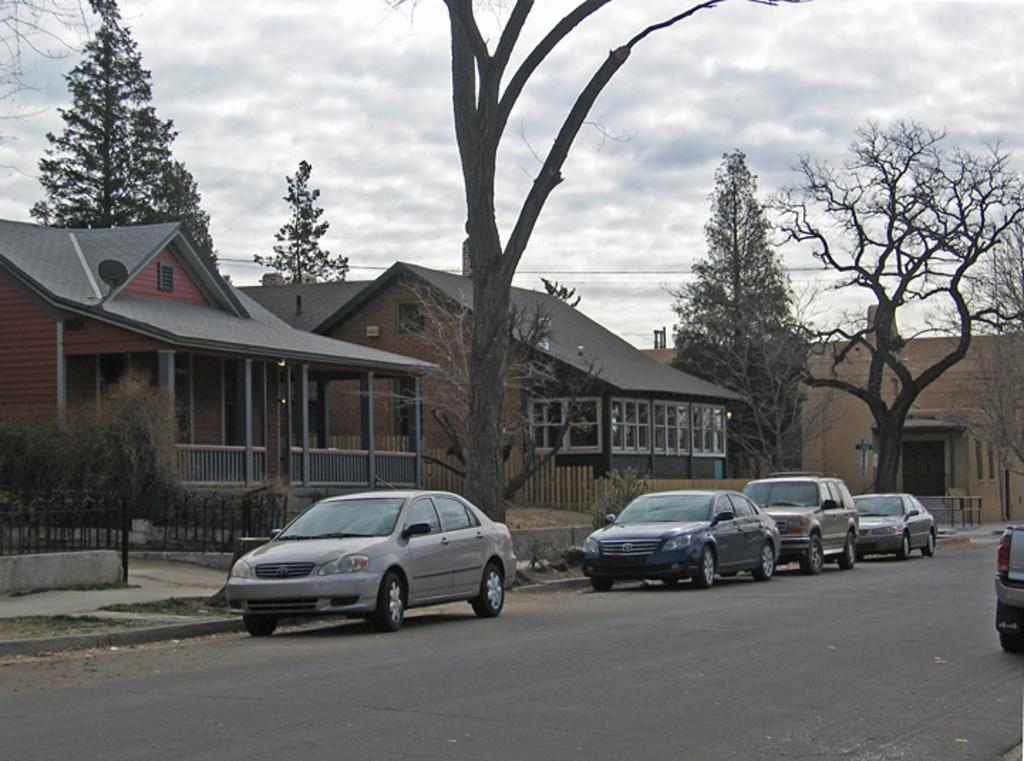Can you describe this image briefly? In the image we can see there are many vehicles on the road. We can even see there are houses and trees. Here we can see the fence, plant, electric wires and the cloudy sky. 